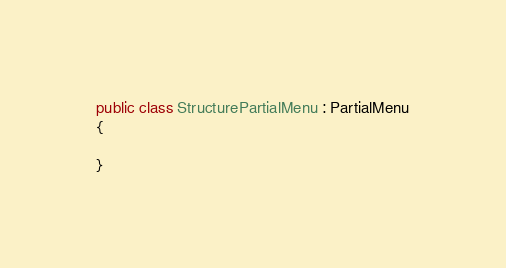Convert code to text. <code><loc_0><loc_0><loc_500><loc_500><_C#_>public class StructurePartialMenu : PartialMenu
{

}
</code> 